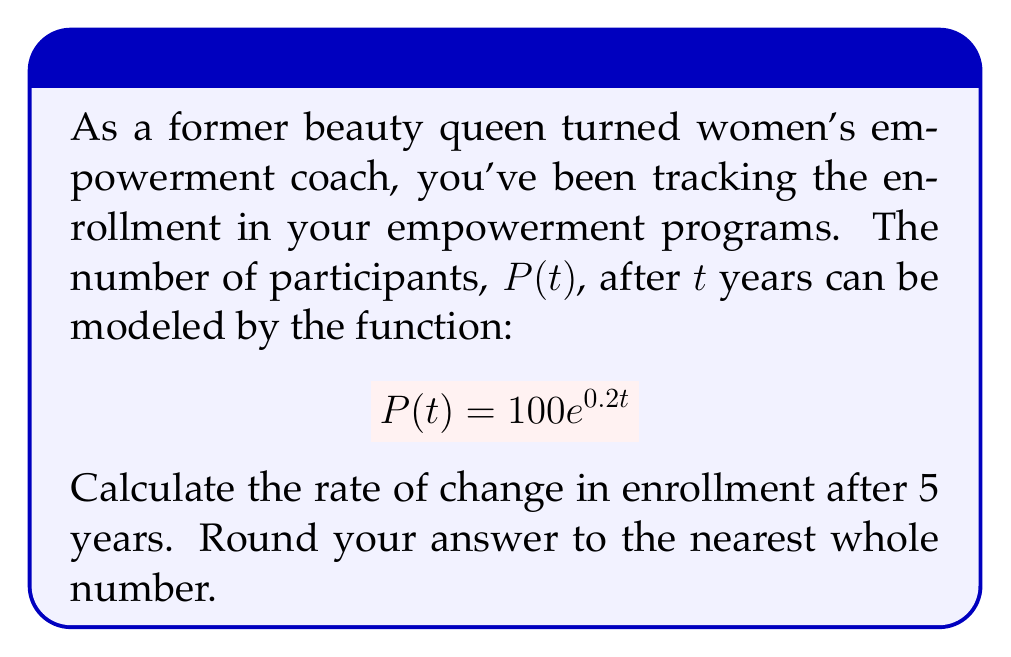Provide a solution to this math problem. To find the rate of change in enrollment after 5 years, we need to calculate the derivative of the given function and evaluate it at t = 5.

Step 1: Find the derivative of $P(t)$.
The derivative of $e^x$ is $e^x$, and we use the chain rule:
$$P'(t) = 100 \cdot 0.2e^{0.2t} = 20e^{0.2t}$$

Step 2: Evaluate $P'(5)$.
$$P'(5) = 20e^{0.2 \cdot 5} = 20e^1 = 20e$$

Step 3: Calculate the value.
$$20e \approx 54.37$$

Step 4: Round to the nearest whole number.
54.37 rounds to 54.

Therefore, the rate of change in enrollment after 5 years is approximately 54 participants per year.
Answer: 54 participants/year 